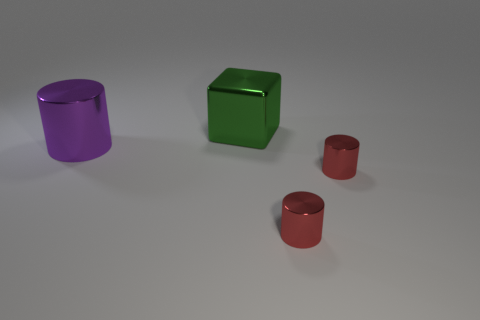What color is the large metallic cube?
Provide a short and direct response. Green. What number of other things are the same size as the purple cylinder?
Provide a short and direct response. 1. The purple thing that is the same material as the large green thing is what size?
Make the answer very short. Large. Is there any other thing of the same color as the large metallic cube?
Ensure brevity in your answer.  No. What is the color of the large metallic thing that is to the left of the metallic block?
Your response must be concise. Purple. Are there fewer shiny cylinders than metal things?
Offer a very short reply. Yes. What number of large metallic things are behind the big metal block?
Your answer should be very brief. 0. What number of metal things are both in front of the large green shiny block and to the right of the purple thing?
Provide a succinct answer. 2. What number of objects are either red things or metallic things to the right of the big green thing?
Your response must be concise. 2. Is the number of yellow cubes greater than the number of big shiny cubes?
Provide a short and direct response. No. 